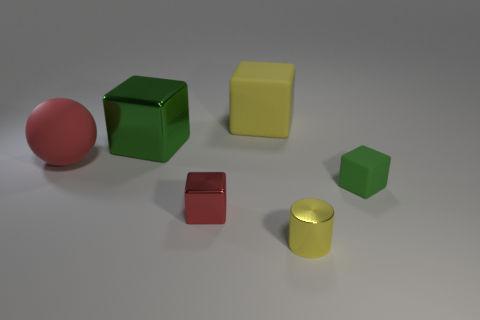What number of other things are there of the same size as the red ball?
Provide a succinct answer. 2. Is the number of matte things that are behind the red rubber object the same as the number of big metallic things?
Ensure brevity in your answer.  Yes. There is a big thing on the right side of the large metal block; does it have the same color as the matte object that is in front of the ball?
Your answer should be very brief. No. What material is the block that is both on the right side of the large green shiny object and behind the tiny green thing?
Provide a succinct answer. Rubber. The large rubber cube has what color?
Your answer should be compact. Yellow. How many other objects are there of the same shape as the small red thing?
Your answer should be very brief. 3. Is the number of small red metal cubes that are in front of the small red object the same as the number of large shiny objects to the right of the big red object?
Ensure brevity in your answer.  No. What material is the red sphere?
Your answer should be very brief. Rubber. There is a green object in front of the ball; what is it made of?
Offer a terse response. Rubber. Are there more objects that are left of the large green cube than red shiny balls?
Provide a succinct answer. Yes. 